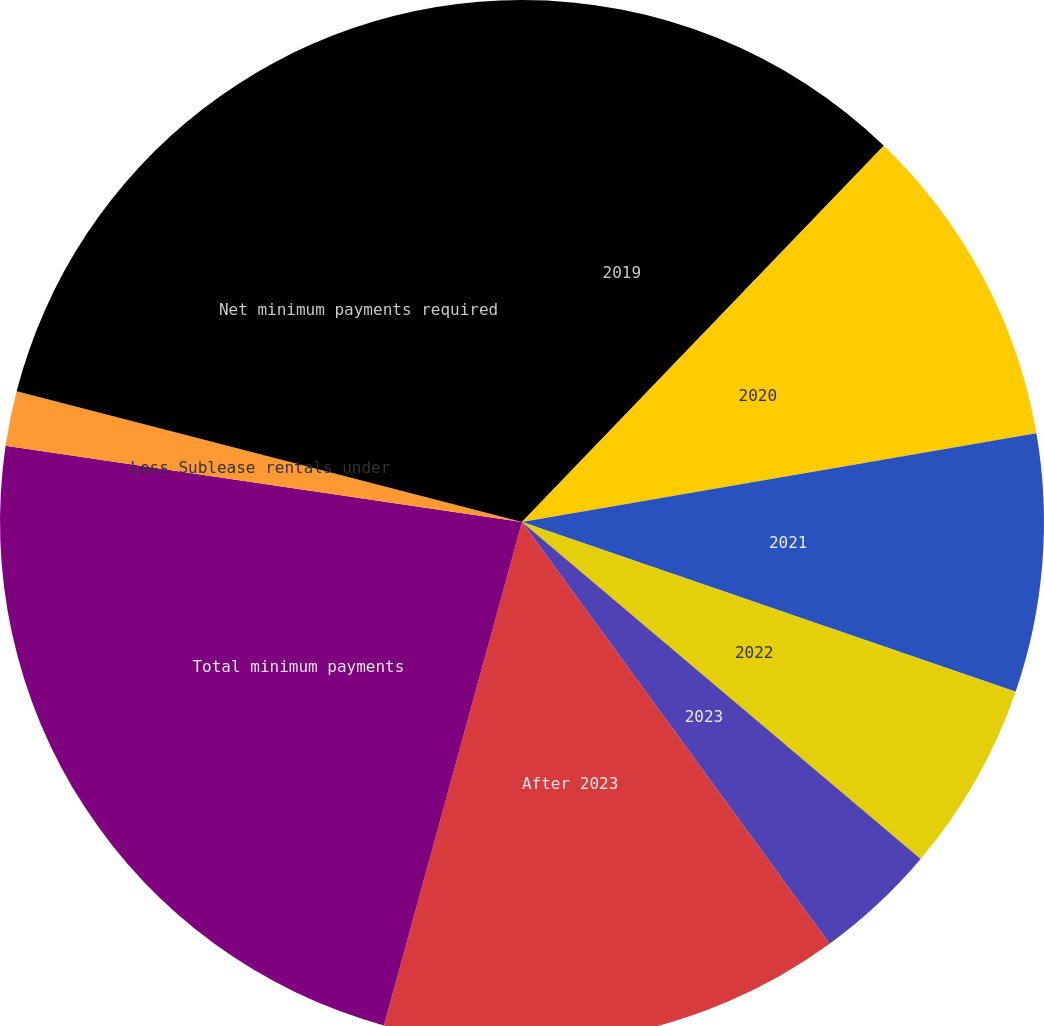Convert chart to OTSL. <chart><loc_0><loc_0><loc_500><loc_500><pie_chart><fcel>2019<fcel>2020<fcel>2021<fcel>2022<fcel>2023<fcel>After 2023<fcel>Total minimum payments<fcel>Less Sublease rentals under<fcel>Net minimum payments required<nl><fcel>12.19%<fcel>10.09%<fcel>7.99%<fcel>5.9%<fcel>3.8%<fcel>14.29%<fcel>23.07%<fcel>1.7%<fcel>20.97%<nl></chart> 